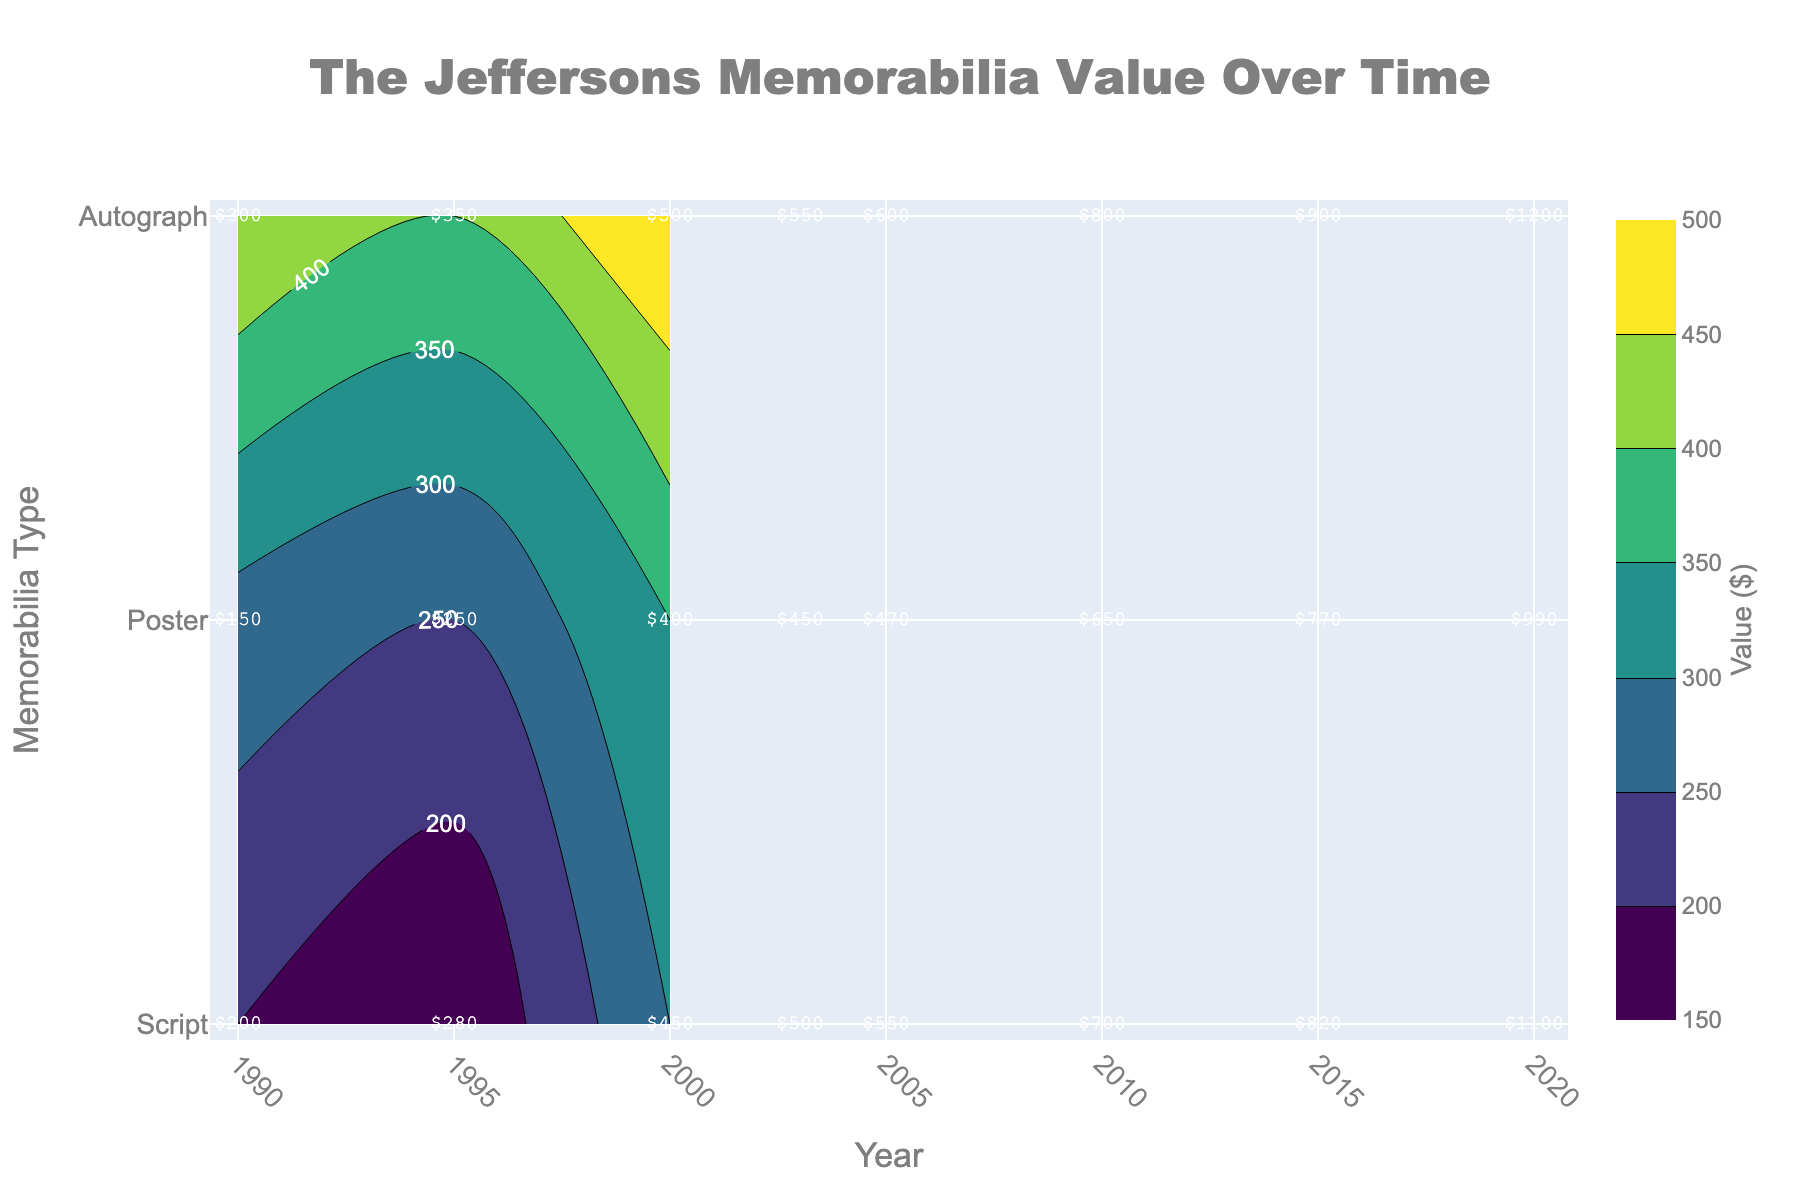What is the title of the plot? The title is written at the top-center of the plot in a large, bold font.
Answer: The Jeffersons Memorabilia Value Over Time How many types of memorabilia are displayed in the plot? The y-axis lists the different memorabilia types, which are Script, Poster, and Autograph.
Answer: 3 In which year was the memorabilia value for Scripts highest? By observing the contour labels and annotations along the x-axis for the "Script" type, the highest value is in 2020.
Answer: 2020 What was the value of Posters in the year 2000? Look at the point where the 2000 year line intersects with the "Poster" row and read the labeled value.
Answer: $400 Compare the values of Autographs and Scripts in 2010. Which one was higher? Examine the plot annotations for 2010 and check the values for "Autograph" and "Script"; Scripts were at $800 and Autographs were at $700.
Answer: Scripts What is the difference in value between Autographs in 1990 and 2020? Find the labeled values for Autographs in 1990 ($200) and 2020 ($1100), then compute the difference: 1100 - 200.
Answer: $900 Which memorabilia type had the smallest increase in value from 1990 to 2020? Calculate the difference in value from 1990 to 2020 for each type: Script (1200 - 300 = 900), Poster (990 - 150 = 840), Autograph (1100 - 200 = 900). Posters had the smallest increase.
Answer: Poster What was the average value of all memorabilia types in the year 2005? Sum the values of all types in 2005 (Script: 600, Poster: 470, Autograph: 550), then divide by the number of types (3): (600 + 470 + 550) / 3 = 1620 / 3.
Answer: $540 How did the value of Posters change from 1995 to 2010? Observe the labeled values for Posters in 1995 ($250) and 2010 ($650). The change is calculated as 650 - 250.
Answer: $400 What is the color scale used in the contour plot? The color scale is shown as a gradient bar next to the plot; it is labeled "Value ($)" and transitions from dark to bright, identified by the 'Viridis' color scheme.
Answer: Viridis 